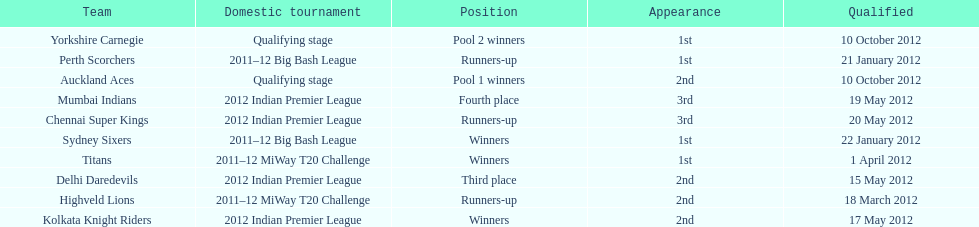Which team made their first appearance in the same tournament as the perth scorchers? Sydney Sixers. 